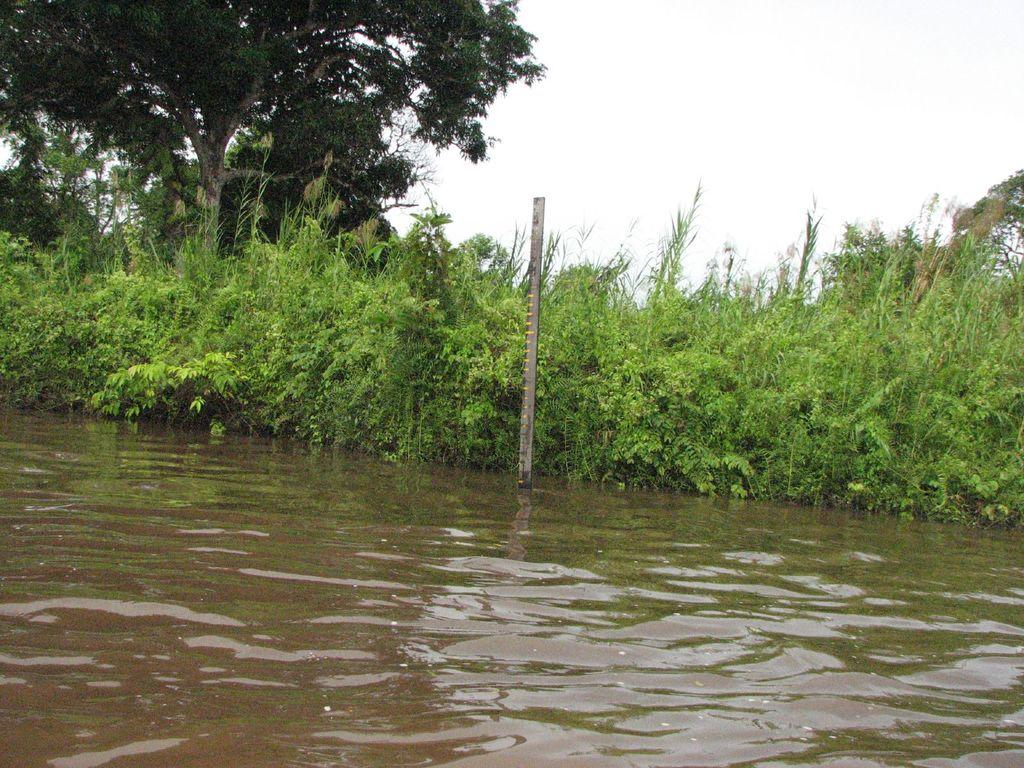What is the primary element visible in the image? There is water in the image. What structure can be seen in the image? There is a pole in the image. What type of vegetation is present in the image? There are plants and trees in the image. What can be seen in the background of the image? The sky is visible in the background of the image. What type of vein is visible in the image? There is no vein present in the image. What feeling is being expressed by the water in the image? The water in the image is not expressing any feeling, as it is an inanimate object. 